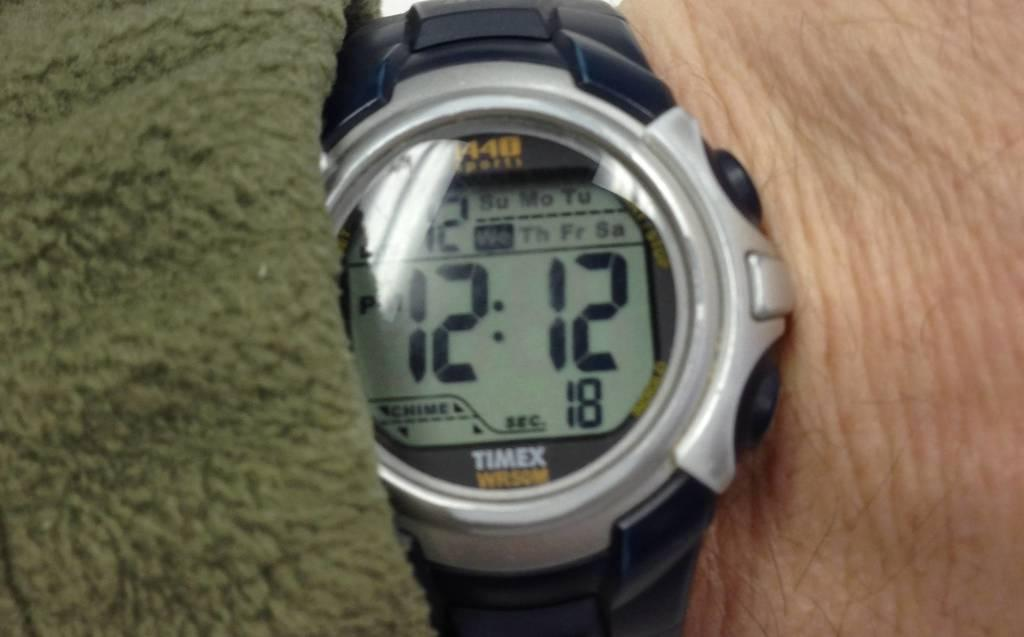<image>
Describe the image concisely. A black watch from Timex with the time of 12:12 and 18 sec. 